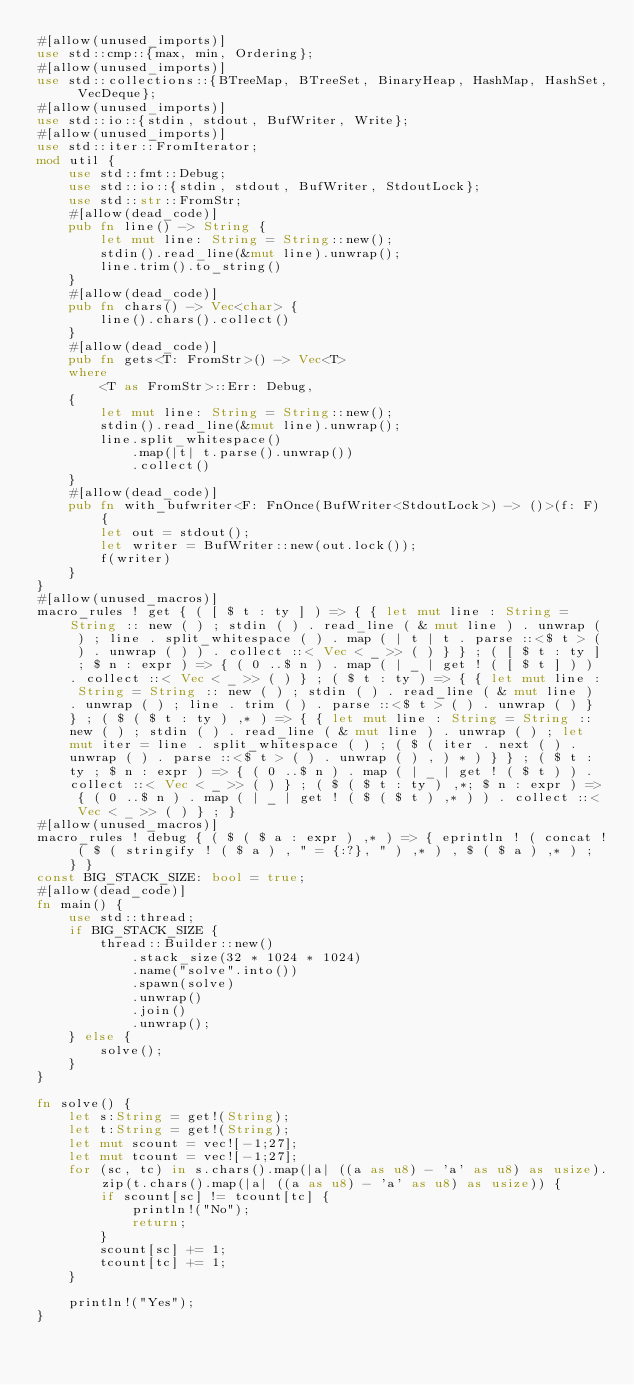Convert code to text. <code><loc_0><loc_0><loc_500><loc_500><_Rust_>#[allow(unused_imports)]
use std::cmp::{max, min, Ordering};
#[allow(unused_imports)]
use std::collections::{BTreeMap, BTreeSet, BinaryHeap, HashMap, HashSet, VecDeque};
#[allow(unused_imports)]
use std::io::{stdin, stdout, BufWriter, Write};
#[allow(unused_imports)]
use std::iter::FromIterator;
mod util {
    use std::fmt::Debug;
    use std::io::{stdin, stdout, BufWriter, StdoutLock};
    use std::str::FromStr;
    #[allow(dead_code)]
    pub fn line() -> String {
        let mut line: String = String::new();
        stdin().read_line(&mut line).unwrap();
        line.trim().to_string()
    }
    #[allow(dead_code)]
    pub fn chars() -> Vec<char> {
        line().chars().collect()
    }
    #[allow(dead_code)]
    pub fn gets<T: FromStr>() -> Vec<T>
    where
        <T as FromStr>::Err: Debug,
    {
        let mut line: String = String::new();
        stdin().read_line(&mut line).unwrap();
        line.split_whitespace()
            .map(|t| t.parse().unwrap())
            .collect()
    }
    #[allow(dead_code)]
    pub fn with_bufwriter<F: FnOnce(BufWriter<StdoutLock>) -> ()>(f: F) {
        let out = stdout();
        let writer = BufWriter::new(out.lock());
        f(writer)
    }
}
#[allow(unused_macros)]
macro_rules ! get { ( [ $ t : ty ] ) => { { let mut line : String = String :: new ( ) ; stdin ( ) . read_line ( & mut line ) . unwrap ( ) ; line . split_whitespace ( ) . map ( | t | t . parse ::<$ t > ( ) . unwrap ( ) ) . collect ::< Vec < _ >> ( ) } } ; ( [ $ t : ty ] ; $ n : expr ) => { ( 0 ..$ n ) . map ( | _ | get ! ( [ $ t ] ) ) . collect ::< Vec < _ >> ( ) } ; ( $ t : ty ) => { { let mut line : String = String :: new ( ) ; stdin ( ) . read_line ( & mut line ) . unwrap ( ) ; line . trim ( ) . parse ::<$ t > ( ) . unwrap ( ) } } ; ( $ ( $ t : ty ) ,* ) => { { let mut line : String = String :: new ( ) ; stdin ( ) . read_line ( & mut line ) . unwrap ( ) ; let mut iter = line . split_whitespace ( ) ; ( $ ( iter . next ( ) . unwrap ( ) . parse ::<$ t > ( ) . unwrap ( ) , ) * ) } } ; ( $ t : ty ; $ n : expr ) => { ( 0 ..$ n ) . map ( | _ | get ! ( $ t ) ) . collect ::< Vec < _ >> ( ) } ; ( $ ( $ t : ty ) ,*; $ n : expr ) => { ( 0 ..$ n ) . map ( | _ | get ! ( $ ( $ t ) ,* ) ) . collect ::< Vec < _ >> ( ) } ; }
#[allow(unused_macros)]
macro_rules ! debug { ( $ ( $ a : expr ) ,* ) => { eprintln ! ( concat ! ( $ ( stringify ! ( $ a ) , " = {:?}, " ) ,* ) , $ ( $ a ) ,* ) ; } }
const BIG_STACK_SIZE: bool = true;
#[allow(dead_code)]
fn main() {
    use std::thread;
    if BIG_STACK_SIZE {
        thread::Builder::new()
            .stack_size(32 * 1024 * 1024)
            .name("solve".into())
            .spawn(solve)
            .unwrap()
            .join()
            .unwrap();
    } else {
        solve();
    }
}

fn solve() {
    let s:String = get!(String);
    let t:String = get!(String);
    let mut scount = vec![-1;27];
    let mut tcount = vec![-1;27];
    for (sc, tc) in s.chars().map(|a| ((a as u8) - 'a' as u8) as usize).zip(t.chars().map(|a| ((a as u8) - 'a' as u8) as usize)) {
        if scount[sc] != tcount[tc] {
            println!("No");
            return;
        }
        scount[sc] += 1;
        tcount[tc] += 1;
    }

    println!("Yes");
}
</code> 